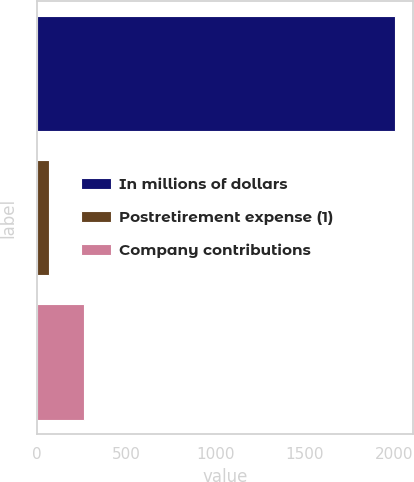<chart> <loc_0><loc_0><loc_500><loc_500><bar_chart><fcel>In millions of dollars<fcel>Postretirement expense (1)<fcel>Company contributions<nl><fcel>2007<fcel>69<fcel>262.8<nl></chart> 